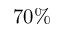<formula> <loc_0><loc_0><loc_500><loc_500>7 0 \%</formula> 